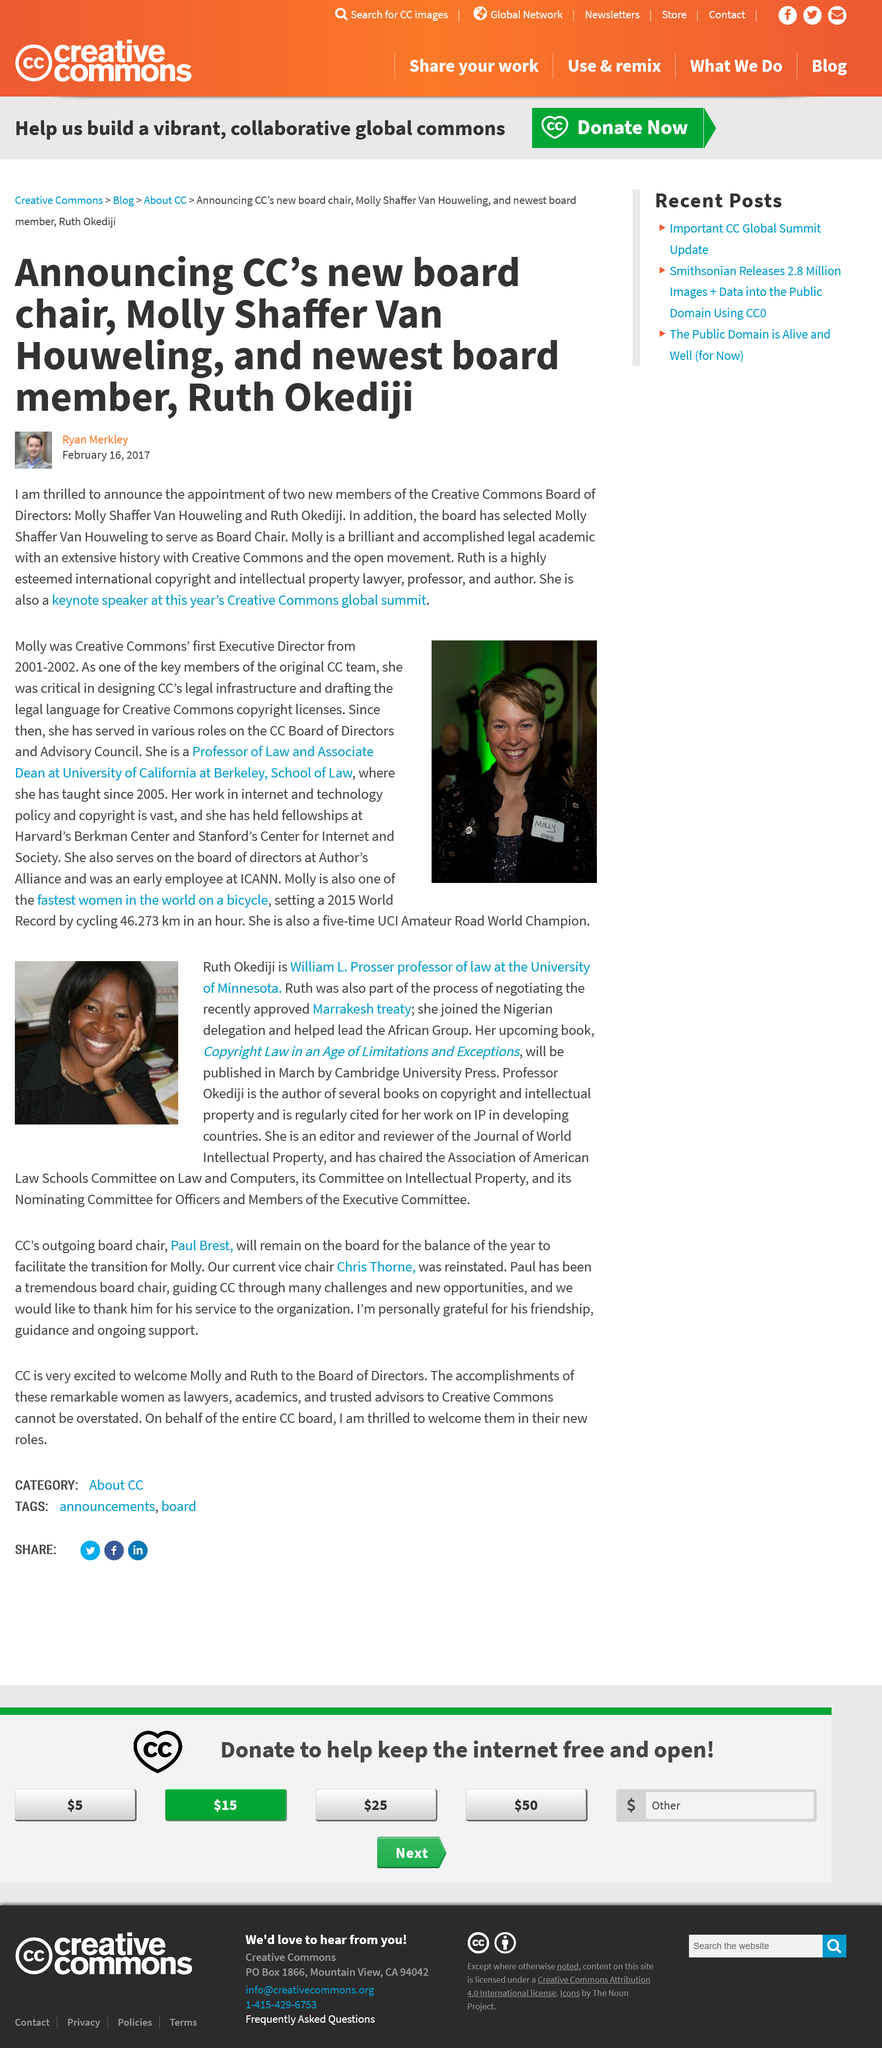Mention a couple of crucial points in this snapshot. Ruth Okediji has been appointed as the new board director of Creative Commons. I, Ruth, helped secure the approval of the Marrakesh treaty. I have learned that the new board chair of CC is Molly Shaffer Van Houweling. Ruth Okediji is the keynote speaker at this year's Creative Commons global summit. Ruth edits and reviews articles on law, computers, and intellectual property. 